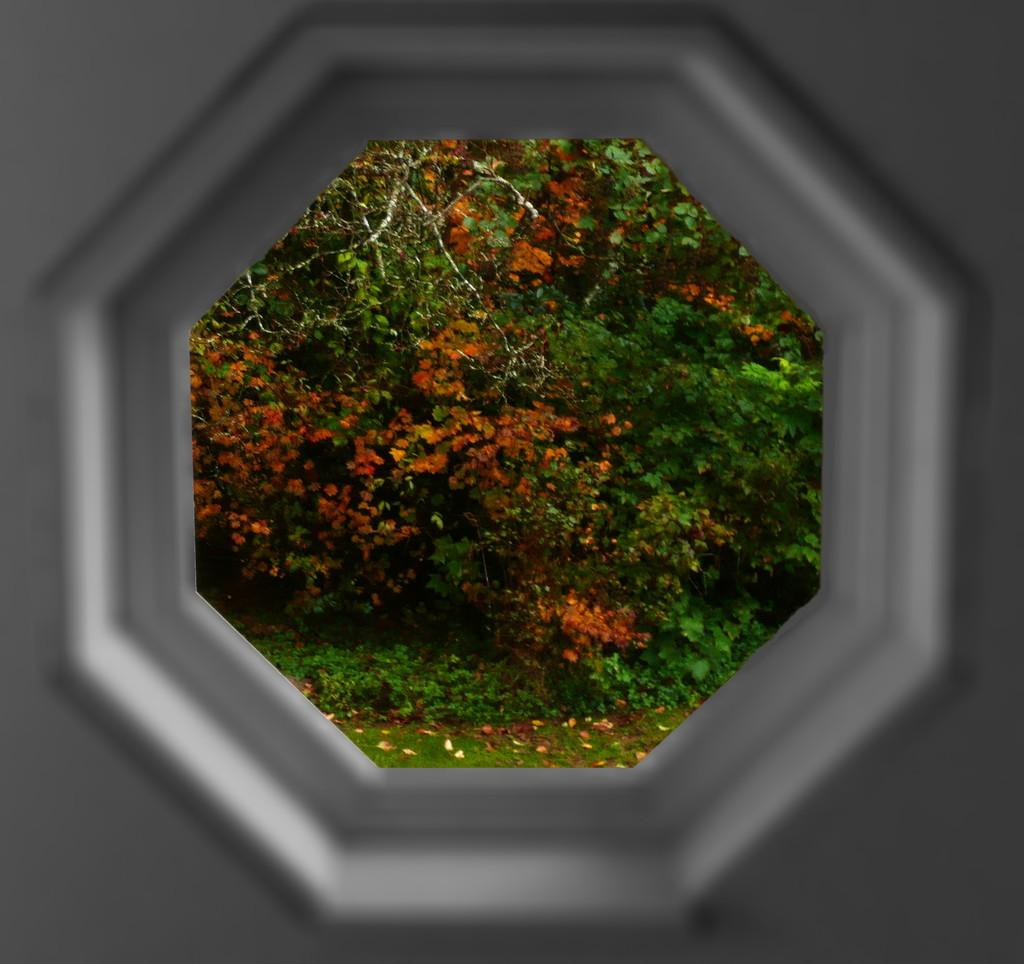What type of vegetation can be seen in the image? There are trees and plants in the image. How are the trees and plants being viewed in the image? The trees and plants are visible through a hexagon. What type of wrist support is visible in the image? There is no wrist support present in the image; it features trees and plants visible through a hexagon. 